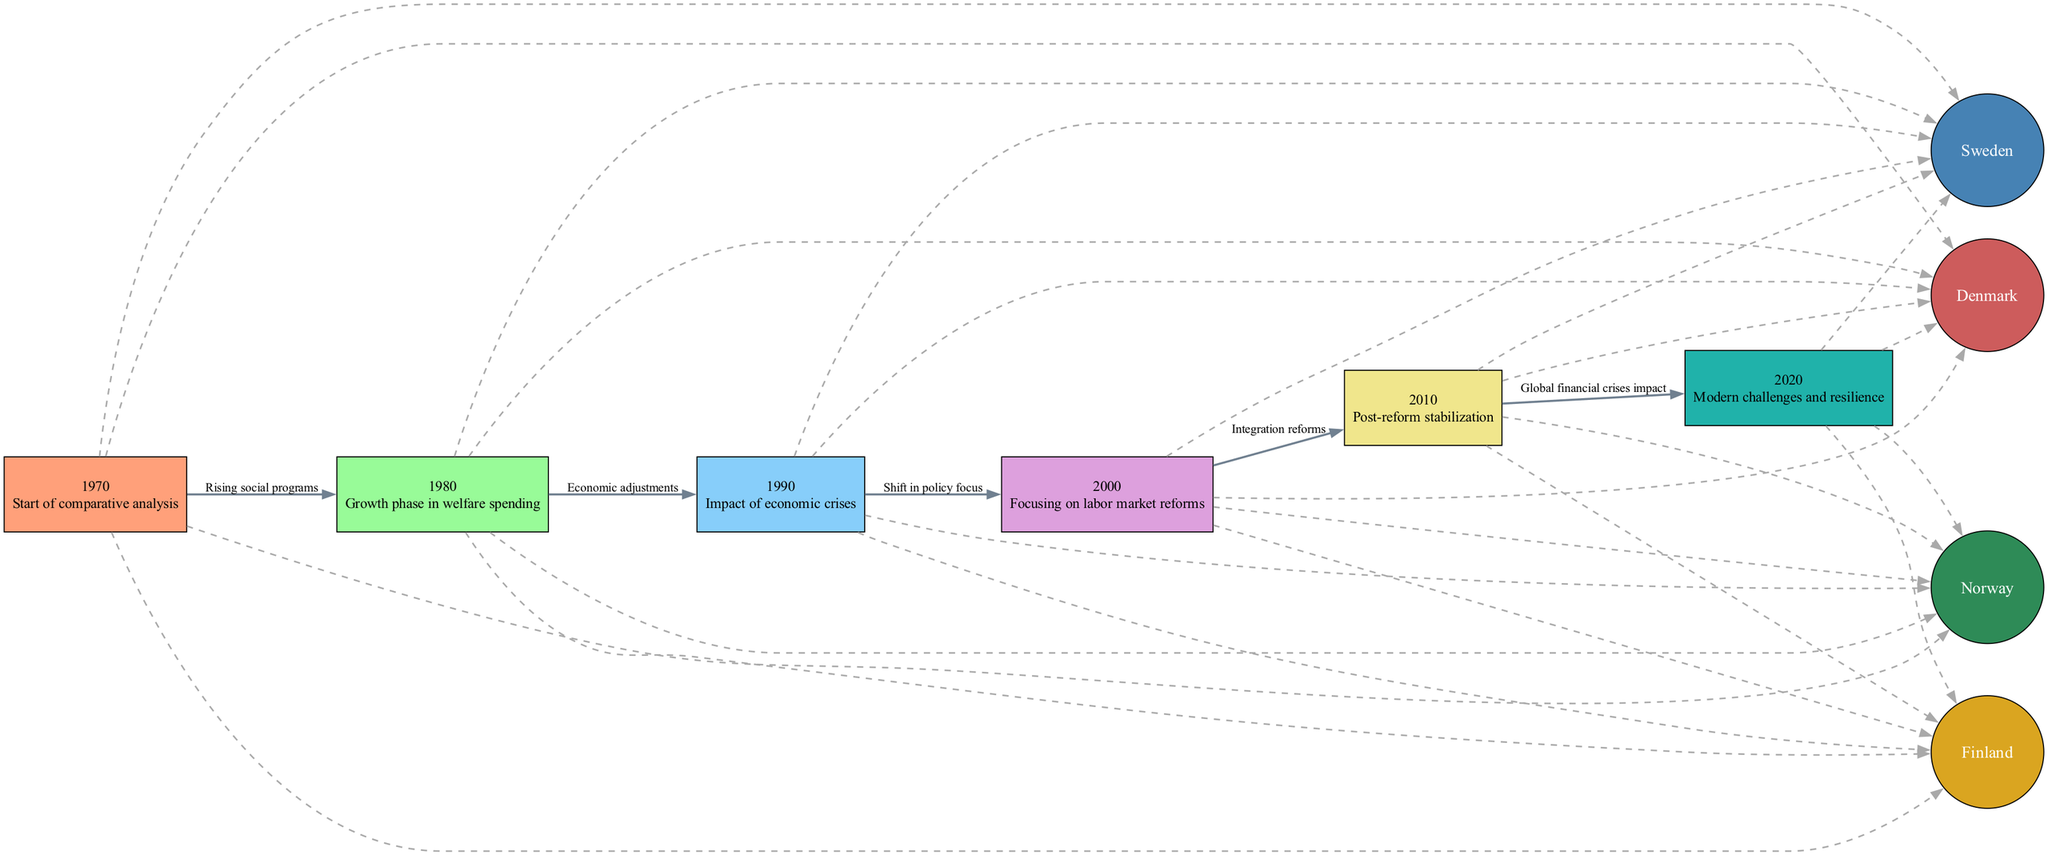What is the starting year of welfare expenditure analysis? The starting year of the comparative analysis is explicitly labeled in the diagram as 1970.
Answer: 1970 How many Scandinavian countries are represented in the diagram? The diagram includes four countries: Sweden, Denmark, Norway, and Finland. This can be determined by counting the specific expenditure nodes.
Answer: Four What phase in welfare spending is represented in 1980? The description for the 1980 node indicates a "Growth phase in welfare spending," which provides context for the significance of this period.
Answer: Growth phase What economic challenge is noted for the year 1990? The node for the year 1990 describes the "Impact of economic crises," indicating that this year was marked by significant economic pressures affecting welfare expenditure.
Answer: Economic crises Which two nodes are connected by the edge labeled "Rising social programs"? The edge labeled "Rising social programs" connects the nodes for the years 1970 and 1980. It indicates the relationship between these two years regarding welfare expenditure trends.
Answer: 1970 and 1980 What is the focus of welfare expenditures in 2000? The description provided for the year 2000 highlights a "Focusing on labor market reforms," informing us that the policies were directed towards addressing labor market issues during this time.
Answer: Labor market reforms How does the diagram illustrate the impact of global financial crises on welfare expenditure? The diagram shows an edge from the node for 2010 to 2020 labeled "Global financial crises impact," suggesting that the financial crises had a lasting effect on welfare policies that continued into 2020.
Answer: Lasting impact Which country's welfare expenditure data is first mentioned in the diagram? The first mention of a country's welfare expenditure is linked to the node for Sweden, as the diagram connects it directly to the starting year of analysis with a "Data source" label.
Answer: Sweden What color represents Norway in the diagram? The diagram uses a distinct fill color identified in the legend for Norway, which is specified as #2E8B57.
Answer: #2E8B57 